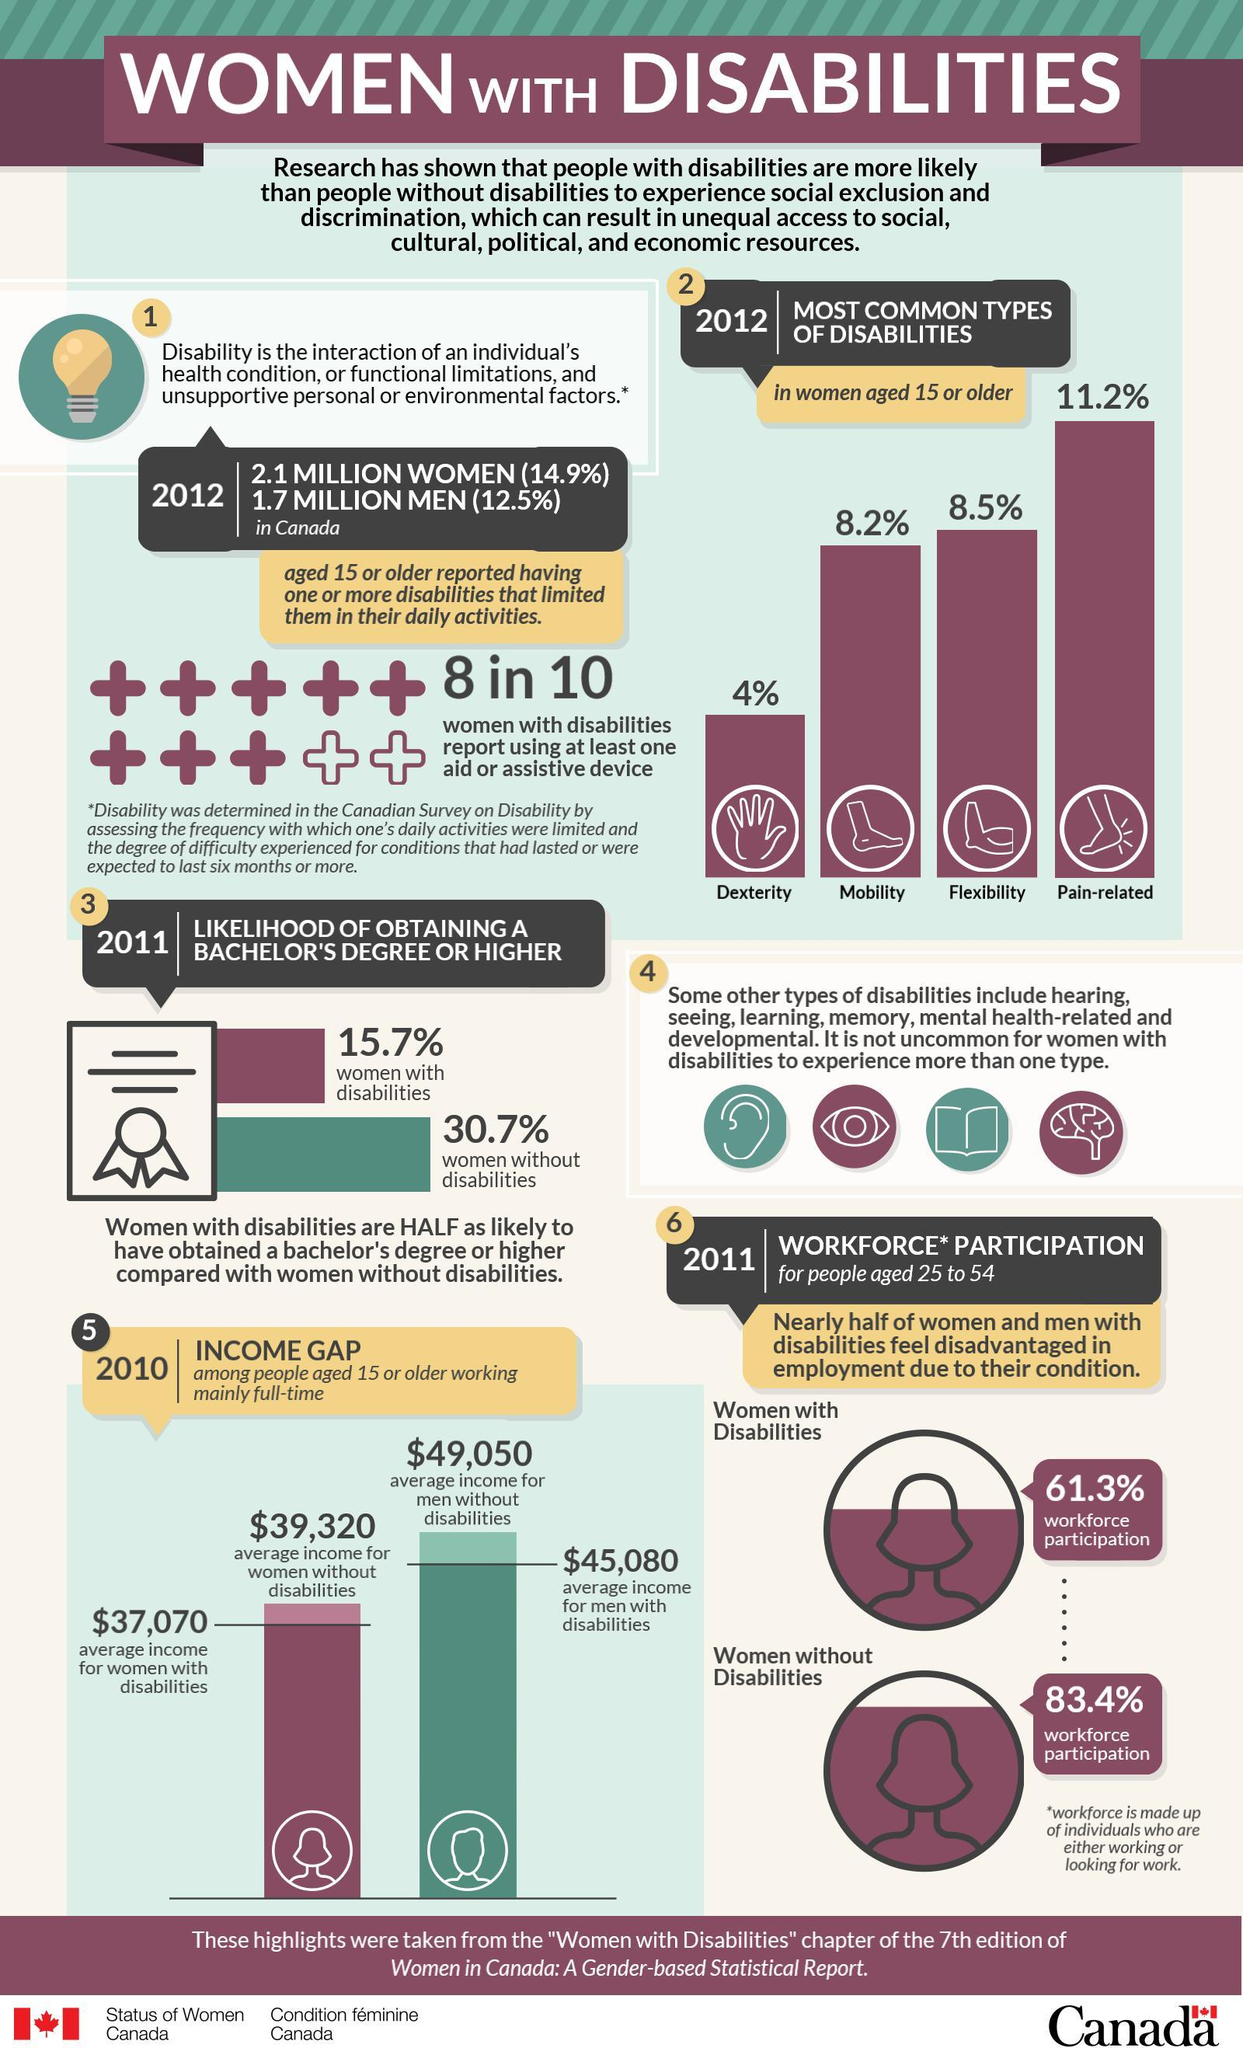Indicate a few pertinent items in this graphic. According to recent statistics, approximately 2.1 million Canadian women are disabled. There are three different types of disability in women other than flexibility. According to the data, mobility disabilities are the third-highest type of disability among women. The second-highest type of disability among women is flexibility, which refers to difficulties in moving and stretching one's body. This can be caused by various conditions such as arthritis, cerebral palsy, or spinal injury. According to a recent study, only 15.7% of disabled women have a high chance of pursuing graduation. 